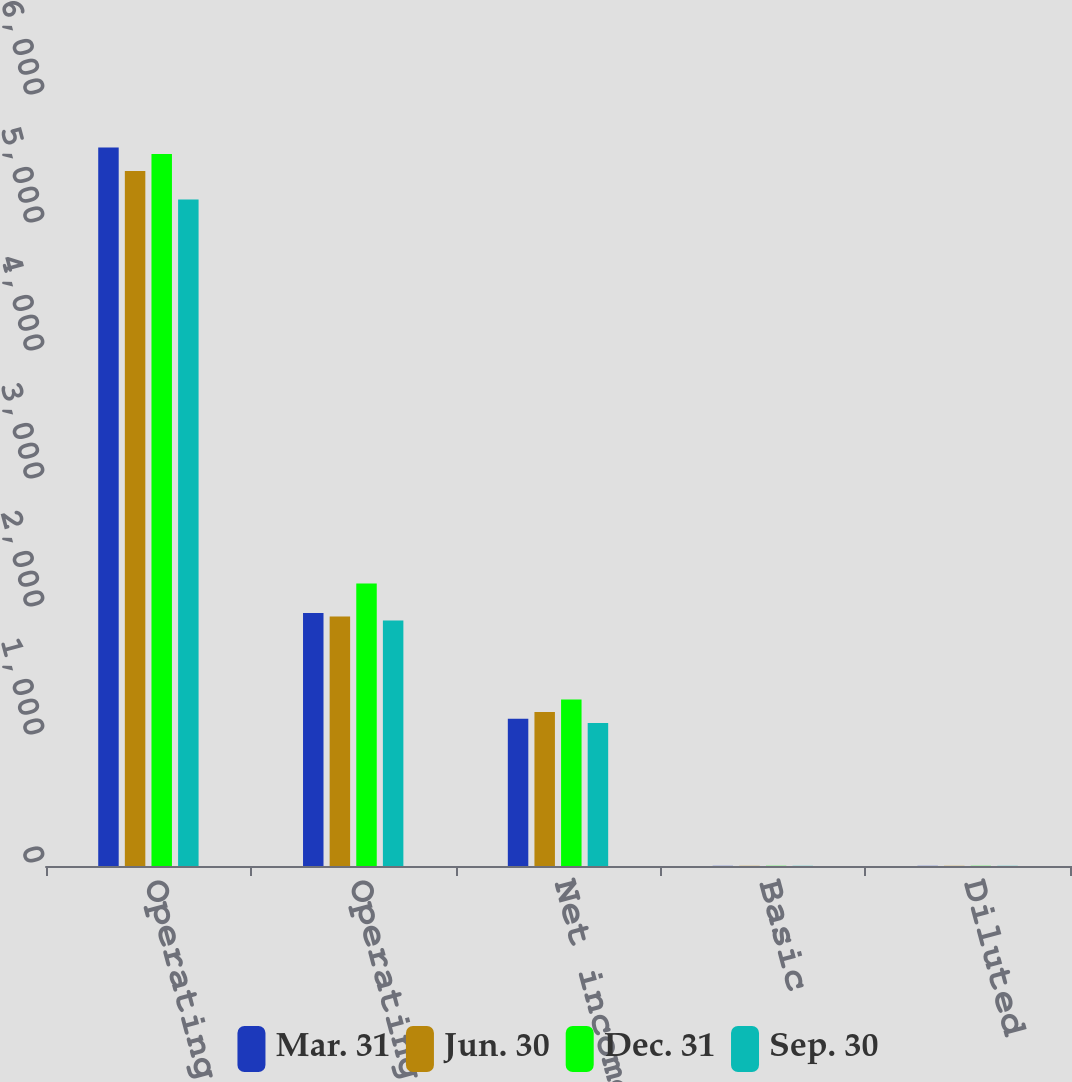Convert chart. <chart><loc_0><loc_0><loc_500><loc_500><stacked_bar_chart><ecel><fcel>Operating revenues<fcel>Operating income<fcel>Net income<fcel>Basic<fcel>Diluted<nl><fcel>Mar. 31<fcel>5614<fcel>1977<fcel>1151<fcel>1.31<fcel>1.3<nl><fcel>Jun. 30<fcel>5429<fcel>1949<fcel>1204<fcel>1.38<fcel>1.38<nl><fcel>Dec. 31<fcel>5562<fcel>2208<fcel>1300<fcel>1.51<fcel>1.5<nl><fcel>Sep. 30<fcel>5208<fcel>1918<fcel>1117<fcel>1.31<fcel>1.31<nl></chart> 